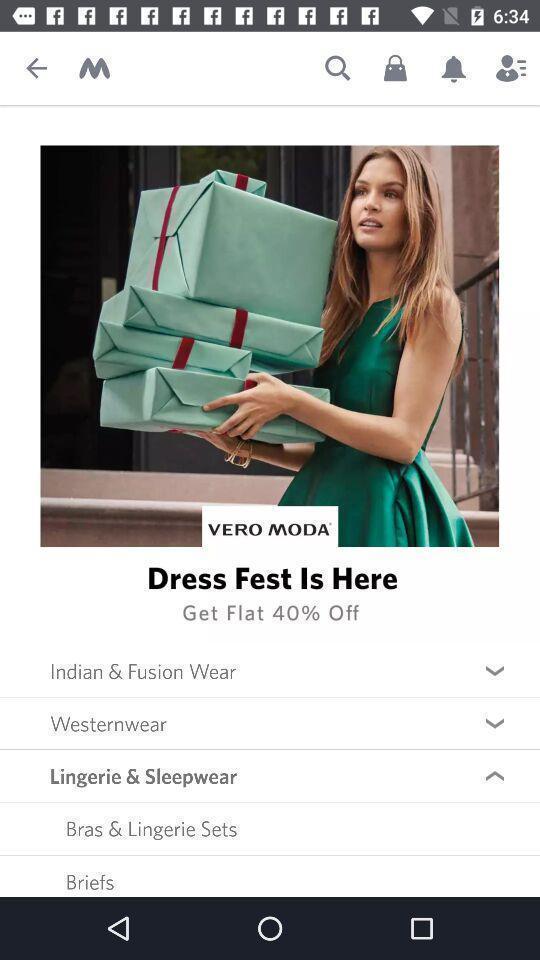Provide a textual representation of this image. Shopping app displayed different categories and other options. 